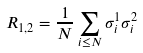<formula> <loc_0><loc_0><loc_500><loc_500>R _ { 1 , 2 } = \frac { 1 } { N } \sum _ { i \leq N } \sigma _ { i } ^ { 1 } \sigma _ { i } ^ { 2 }</formula> 